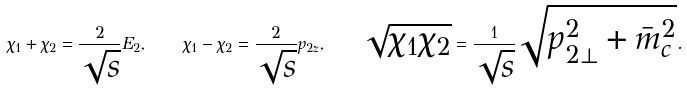Convert formula to latex. <formula><loc_0><loc_0><loc_500><loc_500>\chi _ { 1 } + \chi _ { 2 } = \frac { 2 } { \sqrt { s } } E _ { 2 } , \quad \chi _ { 1 } - \chi _ { 2 } = \frac { 2 } { \sqrt { s } } p _ { 2 z } , \quad \sqrt { \chi _ { 1 } \chi _ { 2 } } = \frac { 1 } { \sqrt { s } } \sqrt { p ^ { 2 } _ { 2 \bot } + \bar { m } _ { c } ^ { 2 } } .</formula> 